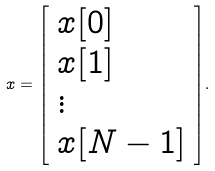Convert formula to latex. <formula><loc_0><loc_0><loc_500><loc_500>x = { \left [ \begin{array} { l } { x [ 0 ] } \\ { x [ 1 ] } \\ { \vdots } \\ { x [ N - 1 ] } \end{array} \right ] } .</formula> 